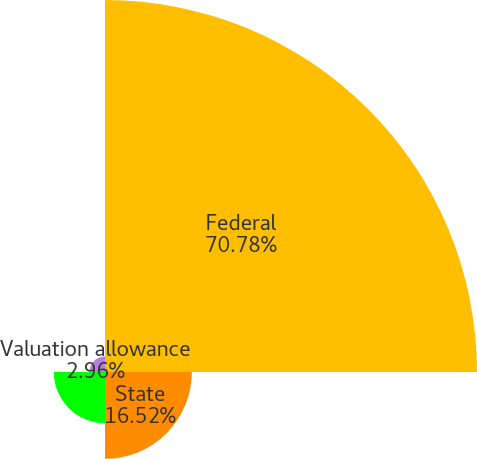Convert chart. <chart><loc_0><loc_0><loc_500><loc_500><pie_chart><fcel>Federal<fcel>State<fcel>Foreign<fcel>Valuation allowance<nl><fcel>70.77%<fcel>16.52%<fcel>9.74%<fcel>2.96%<nl></chart> 